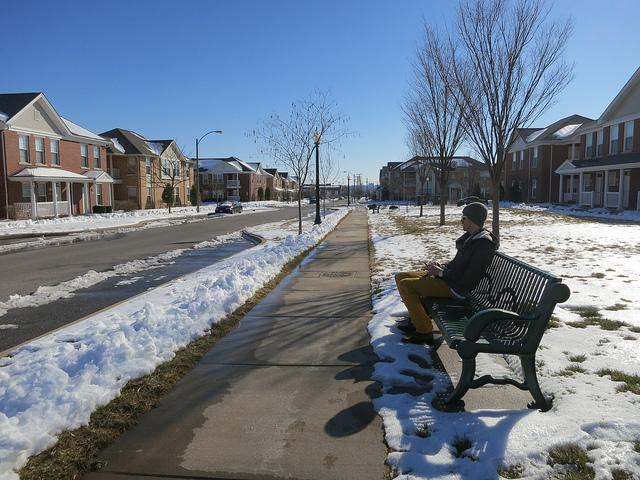In which area does the man wait? bench 